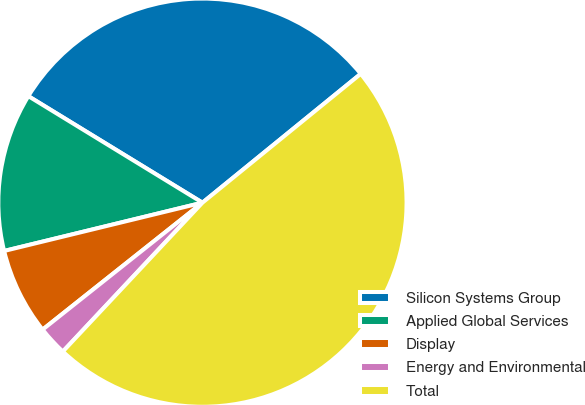Convert chart. <chart><loc_0><loc_0><loc_500><loc_500><pie_chart><fcel>Silicon Systems Group<fcel>Applied Global Services<fcel>Display<fcel>Energy and Environmental<fcel>Total<nl><fcel>30.39%<fcel>12.54%<fcel>6.88%<fcel>2.33%<fcel>47.86%<nl></chart> 